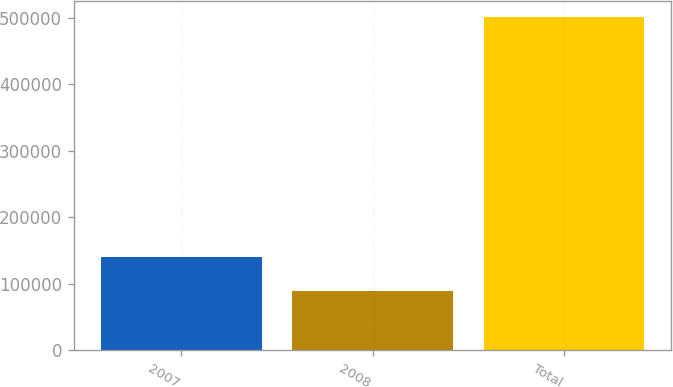Convert chart. <chart><loc_0><loc_0><loc_500><loc_500><bar_chart><fcel>2007<fcel>2008<fcel>Total<nl><fcel>140253<fcel>89358<fcel>500857<nl></chart> 